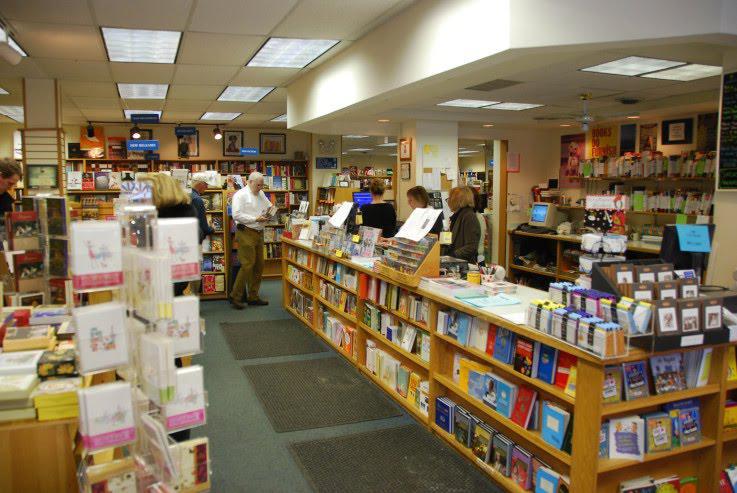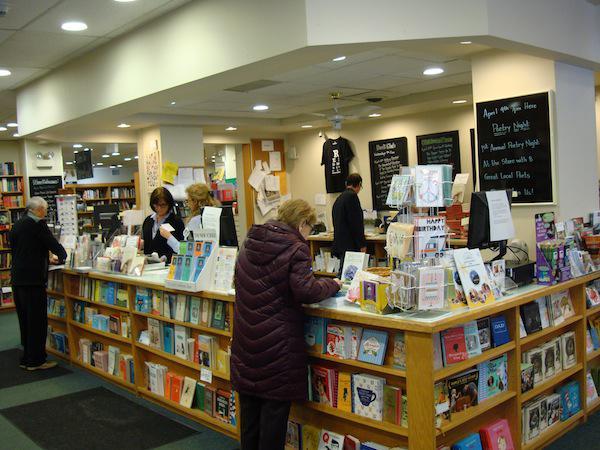The first image is the image on the left, the second image is the image on the right. Examine the images to the left and right. Is the description "At least 2 people are shopping for books in the bookstore." accurate? Answer yes or no. Yes. The first image is the image on the left, the second image is the image on the right. Assess this claim about the two images: "People stand in the book store in the image on the right.". Correct or not? Answer yes or no. Yes. 